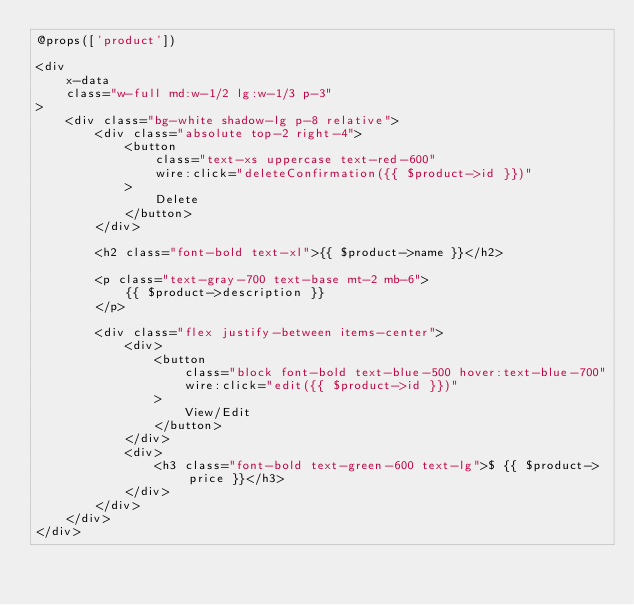Convert code to text. <code><loc_0><loc_0><loc_500><loc_500><_PHP_>@props(['product'])

<div
    x-data
    class="w-full md:w-1/2 lg:w-1/3 p-3"
>
    <div class="bg-white shadow-lg p-8 relative">
        <div class="absolute top-2 right-4">
            <button
                class="text-xs uppercase text-red-600"
                wire:click="deleteConfirmation({{ $product->id }})"
            >
                Delete
            </button>
        </div>

        <h2 class="font-bold text-xl">{{ $product->name }}</h2>

        <p class="text-gray-700 text-base mt-2 mb-6">
            {{ $product->description }}
        </p>

        <div class="flex justify-between items-center">
            <div>
                <button
                    class="block font-bold text-blue-500 hover:text-blue-700"
                    wire:click="edit({{ $product->id }})"
                >
                    View/Edit
                </button>
            </div>
            <div>
                <h3 class="font-bold text-green-600 text-lg">$ {{ $product->price }}</h3>
            </div>
        </div>
    </div>
</div>
</code> 